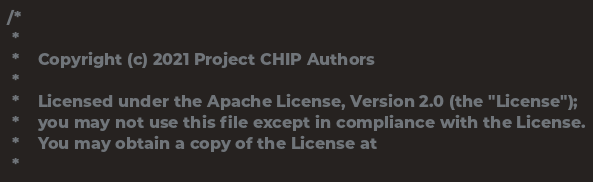Convert code to text. <code><loc_0><loc_0><loc_500><loc_500><_C++_>/*
 *
 *    Copyright (c) 2021 Project CHIP Authors
 *
 *    Licensed under the Apache License, Version 2.0 (the "License");
 *    you may not use this file except in compliance with the License.
 *    You may obtain a copy of the License at
 *</code> 